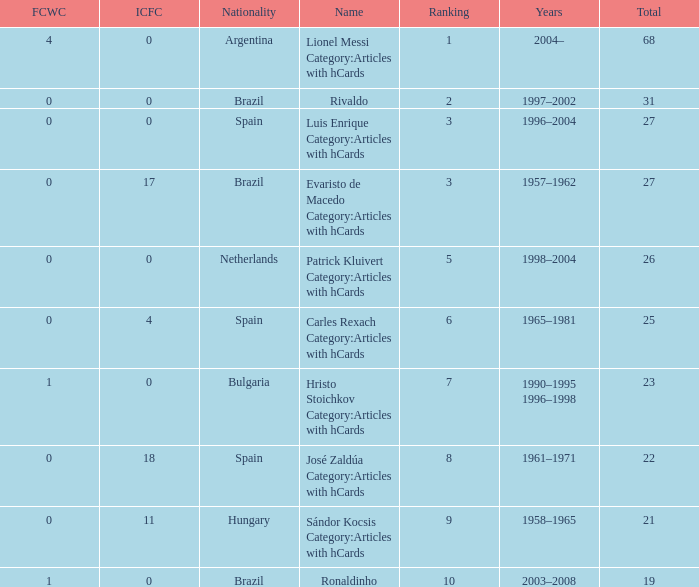What is the highest number of FCWC in the Years of 1958–1965, and an ICFC smaller than 11? None. 